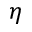<formula> <loc_0><loc_0><loc_500><loc_500>\eta</formula> 